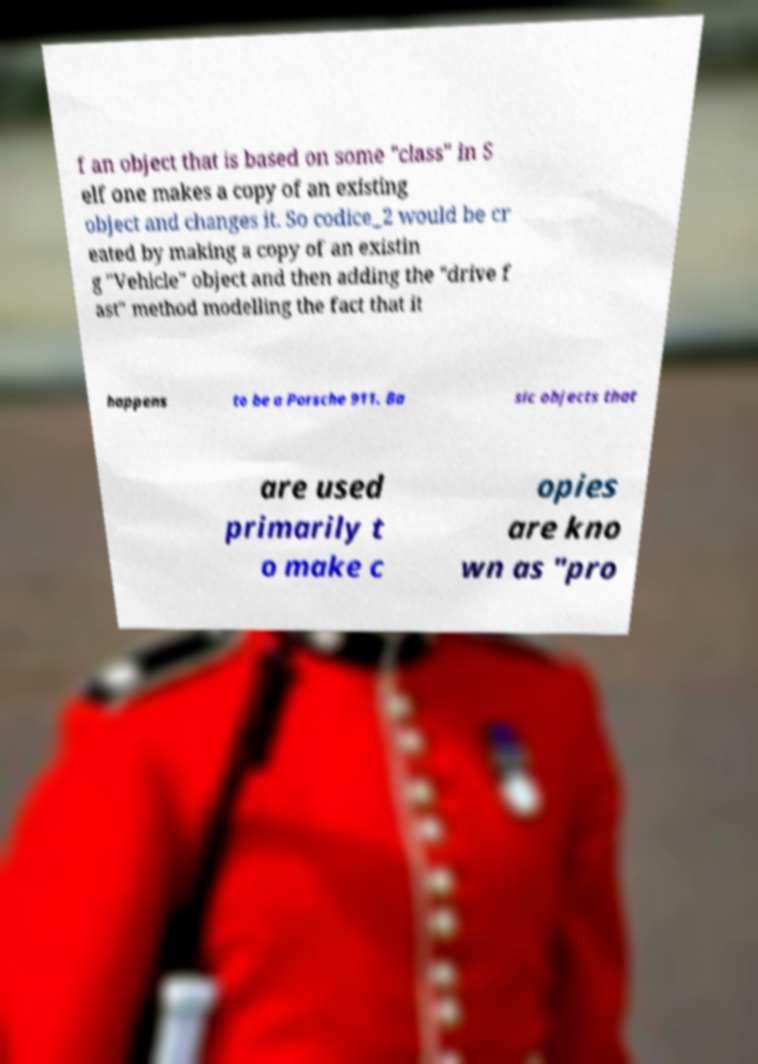Could you assist in decoding the text presented in this image and type it out clearly? f an object that is based on some "class" in S elf one makes a copy of an existing object and changes it. So codice_2 would be cr eated by making a copy of an existin g "Vehicle" object and then adding the "drive f ast" method modelling the fact that it happens to be a Porsche 911. Ba sic objects that are used primarily t o make c opies are kno wn as "pro 